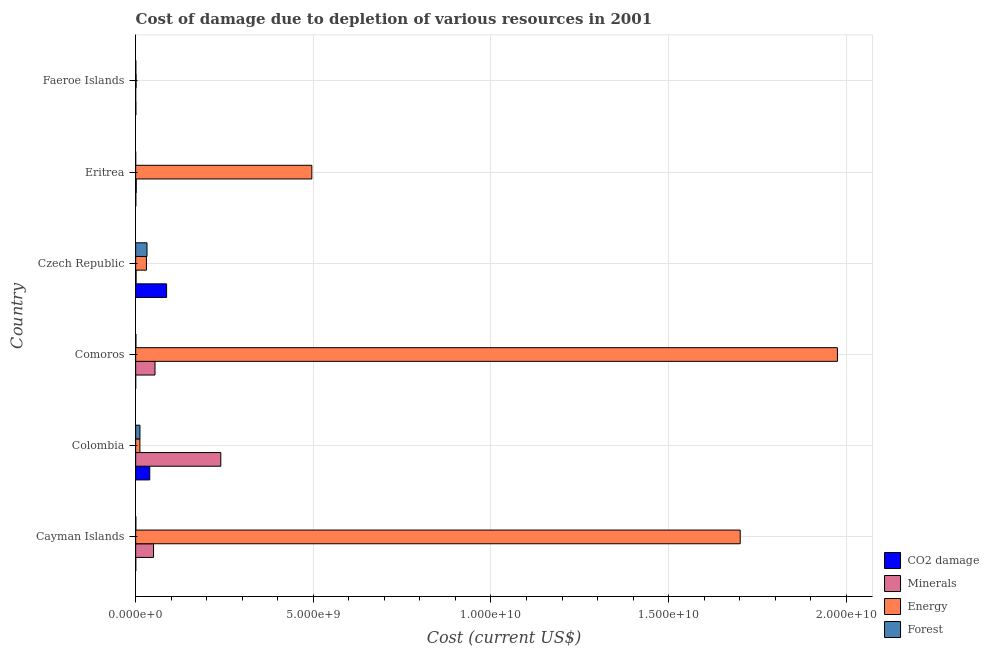How many different coloured bars are there?
Offer a very short reply. 4. Are the number of bars on each tick of the Y-axis equal?
Offer a terse response. Yes. How many bars are there on the 6th tick from the bottom?
Ensure brevity in your answer.  4. What is the label of the 4th group of bars from the top?
Your answer should be compact. Comoros. What is the cost of damage due to depletion of forests in Eritrea?
Your answer should be compact. 4.54e+04. Across all countries, what is the maximum cost of damage due to depletion of energy?
Keep it short and to the point. 1.98e+1. Across all countries, what is the minimum cost of damage due to depletion of minerals?
Ensure brevity in your answer.  1.36e+04. In which country was the cost of damage due to depletion of energy maximum?
Ensure brevity in your answer.  Comoros. In which country was the cost of damage due to depletion of coal minimum?
Give a very brief answer. Comoros. What is the total cost of damage due to depletion of forests in the graph?
Offer a terse response. 4.56e+08. What is the difference between the cost of damage due to depletion of forests in Cayman Islands and that in Colombia?
Offer a terse response. -1.16e+08. What is the difference between the cost of damage due to depletion of energy in Comoros and the cost of damage due to depletion of forests in Cayman Islands?
Provide a short and direct response. 1.97e+1. What is the average cost of damage due to depletion of energy per country?
Ensure brevity in your answer.  7.03e+09. What is the difference between the cost of damage due to depletion of coal and cost of damage due to depletion of forests in Czech Republic?
Keep it short and to the point. 5.52e+08. In how many countries, is the cost of damage due to depletion of minerals greater than 18000000000 US$?
Provide a short and direct response. 0. What is the ratio of the cost of damage due to depletion of energy in Cayman Islands to that in Faeroe Islands?
Ensure brevity in your answer.  1381.44. Is the cost of damage due to depletion of energy in Colombia less than that in Eritrea?
Your answer should be very brief. Yes. Is the difference between the cost of damage due to depletion of minerals in Cayman Islands and Colombia greater than the difference between the cost of damage due to depletion of coal in Cayman Islands and Colombia?
Your answer should be very brief. No. What is the difference between the highest and the second highest cost of damage due to depletion of forests?
Offer a very short reply. 1.98e+08. What is the difference between the highest and the lowest cost of damage due to depletion of energy?
Your response must be concise. 1.97e+1. Is the sum of the cost of damage due to depletion of forests in Cayman Islands and Czech Republic greater than the maximum cost of damage due to depletion of minerals across all countries?
Offer a terse response. No. Is it the case that in every country, the sum of the cost of damage due to depletion of minerals and cost of damage due to depletion of energy is greater than the sum of cost of damage due to depletion of coal and cost of damage due to depletion of forests?
Provide a short and direct response. No. What does the 2nd bar from the top in Cayman Islands represents?
Keep it short and to the point. Energy. What does the 3rd bar from the bottom in Faeroe Islands represents?
Ensure brevity in your answer.  Energy. Is it the case that in every country, the sum of the cost of damage due to depletion of coal and cost of damage due to depletion of minerals is greater than the cost of damage due to depletion of energy?
Your answer should be very brief. No. Are all the bars in the graph horizontal?
Provide a succinct answer. Yes. Does the graph contain any zero values?
Provide a succinct answer. No. Where does the legend appear in the graph?
Offer a very short reply. Bottom right. How are the legend labels stacked?
Offer a terse response. Vertical. What is the title of the graph?
Make the answer very short. Cost of damage due to depletion of various resources in 2001 . Does "Public resource use" appear as one of the legend labels in the graph?
Give a very brief answer. No. What is the label or title of the X-axis?
Offer a very short reply. Cost (current US$). What is the label or title of the Y-axis?
Ensure brevity in your answer.  Country. What is the Cost (current US$) in CO2 damage in Cayman Islands?
Ensure brevity in your answer.  3.20e+06. What is the Cost (current US$) in Minerals in Cayman Islands?
Provide a succinct answer. 5.03e+08. What is the Cost (current US$) of Energy in Cayman Islands?
Your answer should be very brief. 1.70e+1. What is the Cost (current US$) of Forest in Cayman Islands?
Your answer should be compact. 4.80e+06. What is the Cost (current US$) of CO2 damage in Colombia?
Your answer should be compact. 3.97e+08. What is the Cost (current US$) of Minerals in Colombia?
Offer a very short reply. 2.40e+09. What is the Cost (current US$) in Energy in Colombia?
Keep it short and to the point. 1.19e+08. What is the Cost (current US$) in Forest in Colombia?
Make the answer very short. 1.21e+08. What is the Cost (current US$) in CO2 damage in Comoros?
Your response must be concise. 6.20e+05. What is the Cost (current US$) of Minerals in Comoros?
Your answer should be very brief. 5.44e+08. What is the Cost (current US$) in Energy in Comoros?
Keep it short and to the point. 1.98e+1. What is the Cost (current US$) of Forest in Comoros?
Give a very brief answer. 7.16e+06. What is the Cost (current US$) in CO2 damage in Czech Republic?
Ensure brevity in your answer.  8.71e+08. What is the Cost (current US$) in Minerals in Czech Republic?
Give a very brief answer. 1.20e+07. What is the Cost (current US$) in Energy in Czech Republic?
Offer a terse response. 3.03e+08. What is the Cost (current US$) of Forest in Czech Republic?
Provide a succinct answer. 3.19e+08. What is the Cost (current US$) of CO2 damage in Eritrea?
Make the answer very short. 4.45e+06. What is the Cost (current US$) of Minerals in Eritrea?
Your answer should be very brief. 1.64e+07. What is the Cost (current US$) in Energy in Eritrea?
Offer a terse response. 4.96e+09. What is the Cost (current US$) of Forest in Eritrea?
Give a very brief answer. 4.54e+04. What is the Cost (current US$) of CO2 damage in Faeroe Islands?
Your response must be concise. 5.38e+06. What is the Cost (current US$) in Minerals in Faeroe Islands?
Make the answer very short. 1.36e+04. What is the Cost (current US$) of Energy in Faeroe Islands?
Offer a very short reply. 1.23e+07. What is the Cost (current US$) in Forest in Faeroe Islands?
Give a very brief answer. 4.43e+06. Across all countries, what is the maximum Cost (current US$) of CO2 damage?
Keep it short and to the point. 8.71e+08. Across all countries, what is the maximum Cost (current US$) in Minerals?
Make the answer very short. 2.40e+09. Across all countries, what is the maximum Cost (current US$) of Energy?
Provide a succinct answer. 1.98e+1. Across all countries, what is the maximum Cost (current US$) in Forest?
Offer a very short reply. 3.19e+08. Across all countries, what is the minimum Cost (current US$) in CO2 damage?
Your answer should be compact. 6.20e+05. Across all countries, what is the minimum Cost (current US$) in Minerals?
Your answer should be compact. 1.36e+04. Across all countries, what is the minimum Cost (current US$) in Energy?
Make the answer very short. 1.23e+07. Across all countries, what is the minimum Cost (current US$) in Forest?
Offer a terse response. 4.54e+04. What is the total Cost (current US$) of CO2 damage in the graph?
Make the answer very short. 1.28e+09. What is the total Cost (current US$) in Minerals in the graph?
Your response must be concise. 3.47e+09. What is the total Cost (current US$) in Energy in the graph?
Ensure brevity in your answer.  4.22e+1. What is the total Cost (current US$) in Forest in the graph?
Your answer should be very brief. 4.56e+08. What is the difference between the Cost (current US$) of CO2 damage in Cayman Islands and that in Colombia?
Offer a very short reply. -3.93e+08. What is the difference between the Cost (current US$) in Minerals in Cayman Islands and that in Colombia?
Make the answer very short. -1.89e+09. What is the difference between the Cost (current US$) of Energy in Cayman Islands and that in Colombia?
Your answer should be compact. 1.69e+1. What is the difference between the Cost (current US$) in Forest in Cayman Islands and that in Colombia?
Give a very brief answer. -1.16e+08. What is the difference between the Cost (current US$) of CO2 damage in Cayman Islands and that in Comoros?
Provide a succinct answer. 2.58e+06. What is the difference between the Cost (current US$) in Minerals in Cayman Islands and that in Comoros?
Make the answer very short. -4.10e+07. What is the difference between the Cost (current US$) in Energy in Cayman Islands and that in Comoros?
Give a very brief answer. -2.74e+09. What is the difference between the Cost (current US$) in Forest in Cayman Islands and that in Comoros?
Make the answer very short. -2.36e+06. What is the difference between the Cost (current US$) of CO2 damage in Cayman Islands and that in Czech Republic?
Provide a short and direct response. -8.68e+08. What is the difference between the Cost (current US$) in Minerals in Cayman Islands and that in Czech Republic?
Offer a very short reply. 4.91e+08. What is the difference between the Cost (current US$) of Energy in Cayman Islands and that in Czech Republic?
Give a very brief answer. 1.67e+1. What is the difference between the Cost (current US$) in Forest in Cayman Islands and that in Czech Republic?
Offer a very short reply. -3.14e+08. What is the difference between the Cost (current US$) of CO2 damage in Cayman Islands and that in Eritrea?
Offer a terse response. -1.24e+06. What is the difference between the Cost (current US$) in Minerals in Cayman Islands and that in Eritrea?
Give a very brief answer. 4.87e+08. What is the difference between the Cost (current US$) in Energy in Cayman Islands and that in Eritrea?
Give a very brief answer. 1.21e+1. What is the difference between the Cost (current US$) of Forest in Cayman Islands and that in Eritrea?
Offer a very short reply. 4.76e+06. What is the difference between the Cost (current US$) of CO2 damage in Cayman Islands and that in Faeroe Islands?
Offer a very short reply. -2.17e+06. What is the difference between the Cost (current US$) in Minerals in Cayman Islands and that in Faeroe Islands?
Your answer should be very brief. 5.03e+08. What is the difference between the Cost (current US$) of Energy in Cayman Islands and that in Faeroe Islands?
Your answer should be very brief. 1.70e+1. What is the difference between the Cost (current US$) in Forest in Cayman Islands and that in Faeroe Islands?
Your answer should be compact. 3.69e+05. What is the difference between the Cost (current US$) in CO2 damage in Colombia and that in Comoros?
Keep it short and to the point. 3.96e+08. What is the difference between the Cost (current US$) of Minerals in Colombia and that in Comoros?
Your answer should be compact. 1.85e+09. What is the difference between the Cost (current US$) in Energy in Colombia and that in Comoros?
Your answer should be compact. -1.96e+1. What is the difference between the Cost (current US$) of Forest in Colombia and that in Comoros?
Keep it short and to the point. 1.14e+08. What is the difference between the Cost (current US$) in CO2 damage in Colombia and that in Czech Republic?
Offer a very short reply. -4.74e+08. What is the difference between the Cost (current US$) of Minerals in Colombia and that in Czech Republic?
Keep it short and to the point. 2.38e+09. What is the difference between the Cost (current US$) in Energy in Colombia and that in Czech Republic?
Ensure brevity in your answer.  -1.84e+08. What is the difference between the Cost (current US$) of Forest in Colombia and that in Czech Republic?
Your answer should be compact. -1.98e+08. What is the difference between the Cost (current US$) of CO2 damage in Colombia and that in Eritrea?
Make the answer very short. 3.92e+08. What is the difference between the Cost (current US$) of Minerals in Colombia and that in Eritrea?
Provide a short and direct response. 2.38e+09. What is the difference between the Cost (current US$) of Energy in Colombia and that in Eritrea?
Your answer should be compact. -4.84e+09. What is the difference between the Cost (current US$) in Forest in Colombia and that in Eritrea?
Offer a very short reply. 1.21e+08. What is the difference between the Cost (current US$) of CO2 damage in Colombia and that in Faeroe Islands?
Give a very brief answer. 3.91e+08. What is the difference between the Cost (current US$) in Minerals in Colombia and that in Faeroe Islands?
Your answer should be very brief. 2.40e+09. What is the difference between the Cost (current US$) in Energy in Colombia and that in Faeroe Islands?
Your response must be concise. 1.07e+08. What is the difference between the Cost (current US$) of Forest in Colombia and that in Faeroe Islands?
Ensure brevity in your answer.  1.16e+08. What is the difference between the Cost (current US$) in CO2 damage in Comoros and that in Czech Republic?
Give a very brief answer. -8.70e+08. What is the difference between the Cost (current US$) in Minerals in Comoros and that in Czech Republic?
Provide a succinct answer. 5.32e+08. What is the difference between the Cost (current US$) in Energy in Comoros and that in Czech Republic?
Your answer should be compact. 1.94e+1. What is the difference between the Cost (current US$) in Forest in Comoros and that in Czech Republic?
Provide a short and direct response. -3.11e+08. What is the difference between the Cost (current US$) of CO2 damage in Comoros and that in Eritrea?
Offer a terse response. -3.82e+06. What is the difference between the Cost (current US$) of Minerals in Comoros and that in Eritrea?
Give a very brief answer. 5.28e+08. What is the difference between the Cost (current US$) of Energy in Comoros and that in Eritrea?
Ensure brevity in your answer.  1.48e+1. What is the difference between the Cost (current US$) in Forest in Comoros and that in Eritrea?
Make the answer very short. 7.11e+06. What is the difference between the Cost (current US$) of CO2 damage in Comoros and that in Faeroe Islands?
Ensure brevity in your answer.  -4.76e+06. What is the difference between the Cost (current US$) in Minerals in Comoros and that in Faeroe Islands?
Make the answer very short. 5.44e+08. What is the difference between the Cost (current US$) of Energy in Comoros and that in Faeroe Islands?
Make the answer very short. 1.97e+1. What is the difference between the Cost (current US$) in Forest in Comoros and that in Faeroe Islands?
Provide a succinct answer. 2.73e+06. What is the difference between the Cost (current US$) of CO2 damage in Czech Republic and that in Eritrea?
Make the answer very short. 8.66e+08. What is the difference between the Cost (current US$) of Minerals in Czech Republic and that in Eritrea?
Offer a terse response. -4.46e+06. What is the difference between the Cost (current US$) in Energy in Czech Republic and that in Eritrea?
Provide a short and direct response. -4.65e+09. What is the difference between the Cost (current US$) in Forest in Czech Republic and that in Eritrea?
Ensure brevity in your answer.  3.19e+08. What is the difference between the Cost (current US$) of CO2 damage in Czech Republic and that in Faeroe Islands?
Provide a succinct answer. 8.65e+08. What is the difference between the Cost (current US$) in Minerals in Czech Republic and that in Faeroe Islands?
Provide a succinct answer. 1.20e+07. What is the difference between the Cost (current US$) of Energy in Czech Republic and that in Faeroe Islands?
Your response must be concise. 2.91e+08. What is the difference between the Cost (current US$) in Forest in Czech Republic and that in Faeroe Islands?
Your answer should be compact. 3.14e+08. What is the difference between the Cost (current US$) of CO2 damage in Eritrea and that in Faeroe Islands?
Your answer should be very brief. -9.30e+05. What is the difference between the Cost (current US$) of Minerals in Eritrea and that in Faeroe Islands?
Offer a terse response. 1.64e+07. What is the difference between the Cost (current US$) in Energy in Eritrea and that in Faeroe Islands?
Make the answer very short. 4.95e+09. What is the difference between the Cost (current US$) in Forest in Eritrea and that in Faeroe Islands?
Your response must be concise. -4.39e+06. What is the difference between the Cost (current US$) in CO2 damage in Cayman Islands and the Cost (current US$) in Minerals in Colombia?
Your response must be concise. -2.39e+09. What is the difference between the Cost (current US$) of CO2 damage in Cayman Islands and the Cost (current US$) of Energy in Colombia?
Keep it short and to the point. -1.16e+08. What is the difference between the Cost (current US$) in CO2 damage in Cayman Islands and the Cost (current US$) in Forest in Colombia?
Keep it short and to the point. -1.18e+08. What is the difference between the Cost (current US$) in Minerals in Cayman Islands and the Cost (current US$) in Energy in Colombia?
Provide a short and direct response. 3.84e+08. What is the difference between the Cost (current US$) in Minerals in Cayman Islands and the Cost (current US$) in Forest in Colombia?
Ensure brevity in your answer.  3.82e+08. What is the difference between the Cost (current US$) of Energy in Cayman Islands and the Cost (current US$) of Forest in Colombia?
Your answer should be compact. 1.69e+1. What is the difference between the Cost (current US$) of CO2 damage in Cayman Islands and the Cost (current US$) of Minerals in Comoros?
Your answer should be compact. -5.41e+08. What is the difference between the Cost (current US$) in CO2 damage in Cayman Islands and the Cost (current US$) in Energy in Comoros?
Give a very brief answer. -1.97e+1. What is the difference between the Cost (current US$) in CO2 damage in Cayman Islands and the Cost (current US$) in Forest in Comoros?
Provide a succinct answer. -3.96e+06. What is the difference between the Cost (current US$) of Minerals in Cayman Islands and the Cost (current US$) of Energy in Comoros?
Your answer should be compact. -1.92e+1. What is the difference between the Cost (current US$) in Minerals in Cayman Islands and the Cost (current US$) in Forest in Comoros?
Provide a short and direct response. 4.96e+08. What is the difference between the Cost (current US$) of Energy in Cayman Islands and the Cost (current US$) of Forest in Comoros?
Offer a very short reply. 1.70e+1. What is the difference between the Cost (current US$) in CO2 damage in Cayman Islands and the Cost (current US$) in Minerals in Czech Republic?
Your answer should be very brief. -8.76e+06. What is the difference between the Cost (current US$) in CO2 damage in Cayman Islands and the Cost (current US$) in Energy in Czech Republic?
Give a very brief answer. -3.00e+08. What is the difference between the Cost (current US$) in CO2 damage in Cayman Islands and the Cost (current US$) in Forest in Czech Republic?
Make the answer very short. -3.15e+08. What is the difference between the Cost (current US$) in Minerals in Cayman Islands and the Cost (current US$) in Energy in Czech Republic?
Ensure brevity in your answer.  2.00e+08. What is the difference between the Cost (current US$) in Minerals in Cayman Islands and the Cost (current US$) in Forest in Czech Republic?
Offer a very short reply. 1.85e+08. What is the difference between the Cost (current US$) of Energy in Cayman Islands and the Cost (current US$) of Forest in Czech Republic?
Offer a terse response. 1.67e+1. What is the difference between the Cost (current US$) in CO2 damage in Cayman Islands and the Cost (current US$) in Minerals in Eritrea?
Offer a very short reply. -1.32e+07. What is the difference between the Cost (current US$) in CO2 damage in Cayman Islands and the Cost (current US$) in Energy in Eritrea?
Give a very brief answer. -4.95e+09. What is the difference between the Cost (current US$) in CO2 damage in Cayman Islands and the Cost (current US$) in Forest in Eritrea?
Offer a terse response. 3.16e+06. What is the difference between the Cost (current US$) of Minerals in Cayman Islands and the Cost (current US$) of Energy in Eritrea?
Give a very brief answer. -4.45e+09. What is the difference between the Cost (current US$) of Minerals in Cayman Islands and the Cost (current US$) of Forest in Eritrea?
Provide a succinct answer. 5.03e+08. What is the difference between the Cost (current US$) in Energy in Cayman Islands and the Cost (current US$) in Forest in Eritrea?
Your answer should be very brief. 1.70e+1. What is the difference between the Cost (current US$) of CO2 damage in Cayman Islands and the Cost (current US$) of Minerals in Faeroe Islands?
Offer a very short reply. 3.19e+06. What is the difference between the Cost (current US$) in CO2 damage in Cayman Islands and the Cost (current US$) in Energy in Faeroe Islands?
Your response must be concise. -9.11e+06. What is the difference between the Cost (current US$) of CO2 damage in Cayman Islands and the Cost (current US$) of Forest in Faeroe Islands?
Make the answer very short. -1.23e+06. What is the difference between the Cost (current US$) in Minerals in Cayman Islands and the Cost (current US$) in Energy in Faeroe Islands?
Keep it short and to the point. 4.91e+08. What is the difference between the Cost (current US$) in Minerals in Cayman Islands and the Cost (current US$) in Forest in Faeroe Islands?
Give a very brief answer. 4.99e+08. What is the difference between the Cost (current US$) of Energy in Cayman Islands and the Cost (current US$) of Forest in Faeroe Islands?
Provide a short and direct response. 1.70e+1. What is the difference between the Cost (current US$) in CO2 damage in Colombia and the Cost (current US$) in Minerals in Comoros?
Ensure brevity in your answer.  -1.48e+08. What is the difference between the Cost (current US$) in CO2 damage in Colombia and the Cost (current US$) in Energy in Comoros?
Provide a short and direct response. -1.94e+1. What is the difference between the Cost (current US$) of CO2 damage in Colombia and the Cost (current US$) of Forest in Comoros?
Make the answer very short. 3.89e+08. What is the difference between the Cost (current US$) in Minerals in Colombia and the Cost (current US$) in Energy in Comoros?
Your answer should be very brief. -1.74e+1. What is the difference between the Cost (current US$) in Minerals in Colombia and the Cost (current US$) in Forest in Comoros?
Offer a terse response. 2.39e+09. What is the difference between the Cost (current US$) of Energy in Colombia and the Cost (current US$) of Forest in Comoros?
Your answer should be compact. 1.12e+08. What is the difference between the Cost (current US$) in CO2 damage in Colombia and the Cost (current US$) in Minerals in Czech Republic?
Ensure brevity in your answer.  3.85e+08. What is the difference between the Cost (current US$) of CO2 damage in Colombia and the Cost (current US$) of Energy in Czech Republic?
Your answer should be compact. 9.35e+07. What is the difference between the Cost (current US$) of CO2 damage in Colombia and the Cost (current US$) of Forest in Czech Republic?
Your response must be concise. 7.80e+07. What is the difference between the Cost (current US$) in Minerals in Colombia and the Cost (current US$) in Energy in Czech Republic?
Offer a terse response. 2.09e+09. What is the difference between the Cost (current US$) of Minerals in Colombia and the Cost (current US$) of Forest in Czech Republic?
Provide a succinct answer. 2.08e+09. What is the difference between the Cost (current US$) in Energy in Colombia and the Cost (current US$) in Forest in Czech Republic?
Your answer should be compact. -2.00e+08. What is the difference between the Cost (current US$) of CO2 damage in Colombia and the Cost (current US$) of Minerals in Eritrea?
Provide a succinct answer. 3.80e+08. What is the difference between the Cost (current US$) in CO2 damage in Colombia and the Cost (current US$) in Energy in Eritrea?
Your answer should be compact. -4.56e+09. What is the difference between the Cost (current US$) of CO2 damage in Colombia and the Cost (current US$) of Forest in Eritrea?
Your answer should be very brief. 3.97e+08. What is the difference between the Cost (current US$) in Minerals in Colombia and the Cost (current US$) in Energy in Eritrea?
Make the answer very short. -2.56e+09. What is the difference between the Cost (current US$) in Minerals in Colombia and the Cost (current US$) in Forest in Eritrea?
Provide a short and direct response. 2.40e+09. What is the difference between the Cost (current US$) in Energy in Colombia and the Cost (current US$) in Forest in Eritrea?
Offer a terse response. 1.19e+08. What is the difference between the Cost (current US$) of CO2 damage in Colombia and the Cost (current US$) of Minerals in Faeroe Islands?
Your answer should be very brief. 3.97e+08. What is the difference between the Cost (current US$) in CO2 damage in Colombia and the Cost (current US$) in Energy in Faeroe Islands?
Make the answer very short. 3.84e+08. What is the difference between the Cost (current US$) of CO2 damage in Colombia and the Cost (current US$) of Forest in Faeroe Islands?
Your answer should be compact. 3.92e+08. What is the difference between the Cost (current US$) of Minerals in Colombia and the Cost (current US$) of Energy in Faeroe Islands?
Provide a short and direct response. 2.38e+09. What is the difference between the Cost (current US$) in Minerals in Colombia and the Cost (current US$) in Forest in Faeroe Islands?
Make the answer very short. 2.39e+09. What is the difference between the Cost (current US$) in Energy in Colombia and the Cost (current US$) in Forest in Faeroe Islands?
Make the answer very short. 1.15e+08. What is the difference between the Cost (current US$) in CO2 damage in Comoros and the Cost (current US$) in Minerals in Czech Republic?
Make the answer very short. -1.13e+07. What is the difference between the Cost (current US$) in CO2 damage in Comoros and the Cost (current US$) in Energy in Czech Republic?
Provide a short and direct response. -3.03e+08. What is the difference between the Cost (current US$) of CO2 damage in Comoros and the Cost (current US$) of Forest in Czech Republic?
Provide a short and direct response. -3.18e+08. What is the difference between the Cost (current US$) in Minerals in Comoros and the Cost (current US$) in Energy in Czech Republic?
Provide a succinct answer. 2.41e+08. What is the difference between the Cost (current US$) of Minerals in Comoros and the Cost (current US$) of Forest in Czech Republic?
Provide a succinct answer. 2.26e+08. What is the difference between the Cost (current US$) in Energy in Comoros and the Cost (current US$) in Forest in Czech Republic?
Give a very brief answer. 1.94e+1. What is the difference between the Cost (current US$) in CO2 damage in Comoros and the Cost (current US$) in Minerals in Eritrea?
Provide a short and direct response. -1.58e+07. What is the difference between the Cost (current US$) of CO2 damage in Comoros and the Cost (current US$) of Energy in Eritrea?
Your answer should be very brief. -4.96e+09. What is the difference between the Cost (current US$) in CO2 damage in Comoros and the Cost (current US$) in Forest in Eritrea?
Offer a terse response. 5.75e+05. What is the difference between the Cost (current US$) in Minerals in Comoros and the Cost (current US$) in Energy in Eritrea?
Your answer should be very brief. -4.41e+09. What is the difference between the Cost (current US$) in Minerals in Comoros and the Cost (current US$) in Forest in Eritrea?
Ensure brevity in your answer.  5.44e+08. What is the difference between the Cost (current US$) in Energy in Comoros and the Cost (current US$) in Forest in Eritrea?
Offer a terse response. 1.98e+1. What is the difference between the Cost (current US$) of CO2 damage in Comoros and the Cost (current US$) of Minerals in Faeroe Islands?
Offer a terse response. 6.07e+05. What is the difference between the Cost (current US$) of CO2 damage in Comoros and the Cost (current US$) of Energy in Faeroe Islands?
Provide a short and direct response. -1.17e+07. What is the difference between the Cost (current US$) in CO2 damage in Comoros and the Cost (current US$) in Forest in Faeroe Islands?
Keep it short and to the point. -3.81e+06. What is the difference between the Cost (current US$) in Minerals in Comoros and the Cost (current US$) in Energy in Faeroe Islands?
Give a very brief answer. 5.32e+08. What is the difference between the Cost (current US$) in Minerals in Comoros and the Cost (current US$) in Forest in Faeroe Islands?
Keep it short and to the point. 5.40e+08. What is the difference between the Cost (current US$) in Energy in Comoros and the Cost (current US$) in Forest in Faeroe Islands?
Give a very brief answer. 1.97e+1. What is the difference between the Cost (current US$) in CO2 damage in Czech Republic and the Cost (current US$) in Minerals in Eritrea?
Give a very brief answer. 8.54e+08. What is the difference between the Cost (current US$) of CO2 damage in Czech Republic and the Cost (current US$) of Energy in Eritrea?
Your response must be concise. -4.09e+09. What is the difference between the Cost (current US$) in CO2 damage in Czech Republic and the Cost (current US$) in Forest in Eritrea?
Your response must be concise. 8.71e+08. What is the difference between the Cost (current US$) of Minerals in Czech Republic and the Cost (current US$) of Energy in Eritrea?
Ensure brevity in your answer.  -4.95e+09. What is the difference between the Cost (current US$) of Minerals in Czech Republic and the Cost (current US$) of Forest in Eritrea?
Provide a succinct answer. 1.19e+07. What is the difference between the Cost (current US$) of Energy in Czech Republic and the Cost (current US$) of Forest in Eritrea?
Offer a very short reply. 3.03e+08. What is the difference between the Cost (current US$) in CO2 damage in Czech Republic and the Cost (current US$) in Minerals in Faeroe Islands?
Offer a terse response. 8.71e+08. What is the difference between the Cost (current US$) in CO2 damage in Czech Republic and the Cost (current US$) in Energy in Faeroe Islands?
Give a very brief answer. 8.58e+08. What is the difference between the Cost (current US$) of CO2 damage in Czech Republic and the Cost (current US$) of Forest in Faeroe Islands?
Make the answer very short. 8.66e+08. What is the difference between the Cost (current US$) of Minerals in Czech Republic and the Cost (current US$) of Energy in Faeroe Islands?
Keep it short and to the point. -3.51e+05. What is the difference between the Cost (current US$) in Minerals in Czech Republic and the Cost (current US$) in Forest in Faeroe Islands?
Provide a succinct answer. 7.53e+06. What is the difference between the Cost (current US$) in Energy in Czech Republic and the Cost (current US$) in Forest in Faeroe Islands?
Ensure brevity in your answer.  2.99e+08. What is the difference between the Cost (current US$) in CO2 damage in Eritrea and the Cost (current US$) in Minerals in Faeroe Islands?
Your answer should be very brief. 4.43e+06. What is the difference between the Cost (current US$) in CO2 damage in Eritrea and the Cost (current US$) in Energy in Faeroe Islands?
Your answer should be compact. -7.87e+06. What is the difference between the Cost (current US$) in CO2 damage in Eritrea and the Cost (current US$) in Forest in Faeroe Islands?
Keep it short and to the point. 1.43e+04. What is the difference between the Cost (current US$) in Minerals in Eritrea and the Cost (current US$) in Energy in Faeroe Islands?
Your response must be concise. 4.11e+06. What is the difference between the Cost (current US$) of Minerals in Eritrea and the Cost (current US$) of Forest in Faeroe Islands?
Your response must be concise. 1.20e+07. What is the difference between the Cost (current US$) of Energy in Eritrea and the Cost (current US$) of Forest in Faeroe Islands?
Keep it short and to the point. 4.95e+09. What is the average Cost (current US$) of CO2 damage per country?
Make the answer very short. 2.13e+08. What is the average Cost (current US$) of Minerals per country?
Provide a short and direct response. 5.79e+08. What is the average Cost (current US$) in Energy per country?
Provide a short and direct response. 7.03e+09. What is the average Cost (current US$) in Forest per country?
Offer a very short reply. 7.60e+07. What is the difference between the Cost (current US$) in CO2 damage and Cost (current US$) in Minerals in Cayman Islands?
Ensure brevity in your answer.  -5.00e+08. What is the difference between the Cost (current US$) of CO2 damage and Cost (current US$) of Energy in Cayman Islands?
Offer a very short reply. -1.70e+1. What is the difference between the Cost (current US$) in CO2 damage and Cost (current US$) in Forest in Cayman Islands?
Your answer should be compact. -1.60e+06. What is the difference between the Cost (current US$) of Minerals and Cost (current US$) of Energy in Cayman Islands?
Offer a very short reply. -1.65e+1. What is the difference between the Cost (current US$) in Minerals and Cost (current US$) in Forest in Cayman Islands?
Provide a short and direct response. 4.98e+08. What is the difference between the Cost (current US$) in Energy and Cost (current US$) in Forest in Cayman Islands?
Your answer should be very brief. 1.70e+1. What is the difference between the Cost (current US$) of CO2 damage and Cost (current US$) of Minerals in Colombia?
Make the answer very short. -2.00e+09. What is the difference between the Cost (current US$) of CO2 damage and Cost (current US$) of Energy in Colombia?
Offer a terse response. 2.77e+08. What is the difference between the Cost (current US$) in CO2 damage and Cost (current US$) in Forest in Colombia?
Your answer should be very brief. 2.76e+08. What is the difference between the Cost (current US$) in Minerals and Cost (current US$) in Energy in Colombia?
Keep it short and to the point. 2.28e+09. What is the difference between the Cost (current US$) of Minerals and Cost (current US$) of Forest in Colombia?
Offer a very short reply. 2.27e+09. What is the difference between the Cost (current US$) in Energy and Cost (current US$) in Forest in Colombia?
Your answer should be very brief. -1.68e+06. What is the difference between the Cost (current US$) in CO2 damage and Cost (current US$) in Minerals in Comoros?
Provide a short and direct response. -5.44e+08. What is the difference between the Cost (current US$) of CO2 damage and Cost (current US$) of Energy in Comoros?
Offer a terse response. -1.98e+1. What is the difference between the Cost (current US$) in CO2 damage and Cost (current US$) in Forest in Comoros?
Your answer should be compact. -6.54e+06. What is the difference between the Cost (current US$) of Minerals and Cost (current US$) of Energy in Comoros?
Provide a succinct answer. -1.92e+1. What is the difference between the Cost (current US$) of Minerals and Cost (current US$) of Forest in Comoros?
Ensure brevity in your answer.  5.37e+08. What is the difference between the Cost (current US$) in Energy and Cost (current US$) in Forest in Comoros?
Your response must be concise. 1.97e+1. What is the difference between the Cost (current US$) of CO2 damage and Cost (current US$) of Minerals in Czech Republic?
Offer a very short reply. 8.59e+08. What is the difference between the Cost (current US$) in CO2 damage and Cost (current US$) in Energy in Czech Republic?
Keep it short and to the point. 5.68e+08. What is the difference between the Cost (current US$) of CO2 damage and Cost (current US$) of Forest in Czech Republic?
Keep it short and to the point. 5.52e+08. What is the difference between the Cost (current US$) of Minerals and Cost (current US$) of Energy in Czech Republic?
Ensure brevity in your answer.  -2.91e+08. What is the difference between the Cost (current US$) in Minerals and Cost (current US$) in Forest in Czech Republic?
Keep it short and to the point. -3.07e+08. What is the difference between the Cost (current US$) of Energy and Cost (current US$) of Forest in Czech Republic?
Offer a terse response. -1.55e+07. What is the difference between the Cost (current US$) in CO2 damage and Cost (current US$) in Minerals in Eritrea?
Your answer should be compact. -1.20e+07. What is the difference between the Cost (current US$) in CO2 damage and Cost (current US$) in Energy in Eritrea?
Offer a very short reply. -4.95e+09. What is the difference between the Cost (current US$) in CO2 damage and Cost (current US$) in Forest in Eritrea?
Offer a very short reply. 4.40e+06. What is the difference between the Cost (current US$) of Minerals and Cost (current US$) of Energy in Eritrea?
Keep it short and to the point. -4.94e+09. What is the difference between the Cost (current US$) of Minerals and Cost (current US$) of Forest in Eritrea?
Provide a succinct answer. 1.64e+07. What is the difference between the Cost (current US$) in Energy and Cost (current US$) in Forest in Eritrea?
Keep it short and to the point. 4.96e+09. What is the difference between the Cost (current US$) in CO2 damage and Cost (current US$) in Minerals in Faeroe Islands?
Your answer should be very brief. 5.36e+06. What is the difference between the Cost (current US$) of CO2 damage and Cost (current US$) of Energy in Faeroe Islands?
Give a very brief answer. -6.94e+06. What is the difference between the Cost (current US$) in CO2 damage and Cost (current US$) in Forest in Faeroe Islands?
Your response must be concise. 9.45e+05. What is the difference between the Cost (current US$) in Minerals and Cost (current US$) in Energy in Faeroe Islands?
Your answer should be very brief. -1.23e+07. What is the difference between the Cost (current US$) in Minerals and Cost (current US$) in Forest in Faeroe Islands?
Keep it short and to the point. -4.42e+06. What is the difference between the Cost (current US$) of Energy and Cost (current US$) of Forest in Faeroe Islands?
Keep it short and to the point. 7.89e+06. What is the ratio of the Cost (current US$) in CO2 damage in Cayman Islands to that in Colombia?
Ensure brevity in your answer.  0.01. What is the ratio of the Cost (current US$) in Minerals in Cayman Islands to that in Colombia?
Keep it short and to the point. 0.21. What is the ratio of the Cost (current US$) in Energy in Cayman Islands to that in Colombia?
Offer a terse response. 142.83. What is the ratio of the Cost (current US$) in Forest in Cayman Islands to that in Colombia?
Keep it short and to the point. 0.04. What is the ratio of the Cost (current US$) in CO2 damage in Cayman Islands to that in Comoros?
Your answer should be compact. 5.17. What is the ratio of the Cost (current US$) of Minerals in Cayman Islands to that in Comoros?
Your answer should be compact. 0.92. What is the ratio of the Cost (current US$) of Energy in Cayman Islands to that in Comoros?
Ensure brevity in your answer.  0.86. What is the ratio of the Cost (current US$) of Forest in Cayman Islands to that in Comoros?
Your answer should be very brief. 0.67. What is the ratio of the Cost (current US$) in CO2 damage in Cayman Islands to that in Czech Republic?
Your answer should be compact. 0. What is the ratio of the Cost (current US$) in Minerals in Cayman Islands to that in Czech Republic?
Give a very brief answer. 42.05. What is the ratio of the Cost (current US$) of Energy in Cayman Islands to that in Czech Republic?
Give a very brief answer. 56.13. What is the ratio of the Cost (current US$) of Forest in Cayman Islands to that in Czech Republic?
Keep it short and to the point. 0.02. What is the ratio of the Cost (current US$) of CO2 damage in Cayman Islands to that in Eritrea?
Offer a very short reply. 0.72. What is the ratio of the Cost (current US$) in Minerals in Cayman Islands to that in Eritrea?
Provide a short and direct response. 30.63. What is the ratio of the Cost (current US$) in Energy in Cayman Islands to that in Eritrea?
Provide a succinct answer. 3.43. What is the ratio of the Cost (current US$) in Forest in Cayman Islands to that in Eritrea?
Your response must be concise. 105.64. What is the ratio of the Cost (current US$) of CO2 damage in Cayman Islands to that in Faeroe Islands?
Provide a succinct answer. 0.6. What is the ratio of the Cost (current US$) in Minerals in Cayman Islands to that in Faeroe Islands?
Offer a terse response. 3.71e+04. What is the ratio of the Cost (current US$) in Energy in Cayman Islands to that in Faeroe Islands?
Ensure brevity in your answer.  1381.44. What is the ratio of the Cost (current US$) in Forest in Cayman Islands to that in Faeroe Islands?
Provide a short and direct response. 1.08. What is the ratio of the Cost (current US$) in CO2 damage in Colombia to that in Comoros?
Keep it short and to the point. 639.42. What is the ratio of the Cost (current US$) in Minerals in Colombia to that in Comoros?
Your response must be concise. 4.4. What is the ratio of the Cost (current US$) of Energy in Colombia to that in Comoros?
Give a very brief answer. 0.01. What is the ratio of the Cost (current US$) in Forest in Colombia to that in Comoros?
Ensure brevity in your answer.  16.87. What is the ratio of the Cost (current US$) in CO2 damage in Colombia to that in Czech Republic?
Keep it short and to the point. 0.46. What is the ratio of the Cost (current US$) of Minerals in Colombia to that in Czech Republic?
Provide a short and direct response. 200.21. What is the ratio of the Cost (current US$) of Energy in Colombia to that in Czech Republic?
Your answer should be very brief. 0.39. What is the ratio of the Cost (current US$) in Forest in Colombia to that in Czech Republic?
Your answer should be very brief. 0.38. What is the ratio of the Cost (current US$) in CO2 damage in Colombia to that in Eritrea?
Provide a succinct answer. 89.22. What is the ratio of the Cost (current US$) of Minerals in Colombia to that in Eritrea?
Offer a terse response. 145.82. What is the ratio of the Cost (current US$) of Energy in Colombia to that in Eritrea?
Offer a very short reply. 0.02. What is the ratio of the Cost (current US$) in Forest in Colombia to that in Eritrea?
Provide a short and direct response. 2658.58. What is the ratio of the Cost (current US$) of CO2 damage in Colombia to that in Faeroe Islands?
Your answer should be compact. 73.78. What is the ratio of the Cost (current US$) in Minerals in Colombia to that in Faeroe Islands?
Give a very brief answer. 1.77e+05. What is the ratio of the Cost (current US$) in Energy in Colombia to that in Faeroe Islands?
Make the answer very short. 9.67. What is the ratio of the Cost (current US$) in Forest in Colombia to that in Faeroe Islands?
Provide a succinct answer. 27.26. What is the ratio of the Cost (current US$) of CO2 damage in Comoros to that in Czech Republic?
Provide a short and direct response. 0. What is the ratio of the Cost (current US$) in Minerals in Comoros to that in Czech Republic?
Your response must be concise. 45.48. What is the ratio of the Cost (current US$) in Energy in Comoros to that in Czech Republic?
Give a very brief answer. 65.16. What is the ratio of the Cost (current US$) of Forest in Comoros to that in Czech Republic?
Provide a short and direct response. 0.02. What is the ratio of the Cost (current US$) in CO2 damage in Comoros to that in Eritrea?
Your answer should be compact. 0.14. What is the ratio of the Cost (current US$) of Minerals in Comoros to that in Eritrea?
Your response must be concise. 33.12. What is the ratio of the Cost (current US$) in Energy in Comoros to that in Eritrea?
Your answer should be very brief. 3.98. What is the ratio of the Cost (current US$) in Forest in Comoros to that in Eritrea?
Your answer should be compact. 157.57. What is the ratio of the Cost (current US$) in CO2 damage in Comoros to that in Faeroe Islands?
Your answer should be very brief. 0.12. What is the ratio of the Cost (current US$) of Minerals in Comoros to that in Faeroe Islands?
Keep it short and to the point. 4.01e+04. What is the ratio of the Cost (current US$) of Energy in Comoros to that in Faeroe Islands?
Provide a succinct answer. 1603.61. What is the ratio of the Cost (current US$) of Forest in Comoros to that in Faeroe Islands?
Your answer should be very brief. 1.62. What is the ratio of the Cost (current US$) in CO2 damage in Czech Republic to that in Eritrea?
Your answer should be compact. 195.88. What is the ratio of the Cost (current US$) of Minerals in Czech Republic to that in Eritrea?
Provide a short and direct response. 0.73. What is the ratio of the Cost (current US$) in Energy in Czech Republic to that in Eritrea?
Make the answer very short. 0.06. What is the ratio of the Cost (current US$) of Forest in Czech Republic to that in Eritrea?
Ensure brevity in your answer.  7012.05. What is the ratio of the Cost (current US$) of CO2 damage in Czech Republic to that in Faeroe Islands?
Give a very brief answer. 161.98. What is the ratio of the Cost (current US$) in Minerals in Czech Republic to that in Faeroe Islands?
Ensure brevity in your answer.  882.42. What is the ratio of the Cost (current US$) in Energy in Czech Republic to that in Faeroe Islands?
Give a very brief answer. 24.61. What is the ratio of the Cost (current US$) of Forest in Czech Republic to that in Faeroe Islands?
Offer a terse response. 71.91. What is the ratio of the Cost (current US$) of CO2 damage in Eritrea to that in Faeroe Islands?
Provide a short and direct response. 0.83. What is the ratio of the Cost (current US$) in Minerals in Eritrea to that in Faeroe Islands?
Your response must be concise. 1211.59. What is the ratio of the Cost (current US$) of Energy in Eritrea to that in Faeroe Islands?
Offer a very short reply. 402.54. What is the ratio of the Cost (current US$) in Forest in Eritrea to that in Faeroe Islands?
Give a very brief answer. 0.01. What is the difference between the highest and the second highest Cost (current US$) in CO2 damage?
Your answer should be very brief. 4.74e+08. What is the difference between the highest and the second highest Cost (current US$) of Minerals?
Ensure brevity in your answer.  1.85e+09. What is the difference between the highest and the second highest Cost (current US$) in Energy?
Offer a terse response. 2.74e+09. What is the difference between the highest and the second highest Cost (current US$) of Forest?
Your response must be concise. 1.98e+08. What is the difference between the highest and the lowest Cost (current US$) in CO2 damage?
Ensure brevity in your answer.  8.70e+08. What is the difference between the highest and the lowest Cost (current US$) of Minerals?
Ensure brevity in your answer.  2.40e+09. What is the difference between the highest and the lowest Cost (current US$) in Energy?
Your response must be concise. 1.97e+1. What is the difference between the highest and the lowest Cost (current US$) in Forest?
Offer a very short reply. 3.19e+08. 